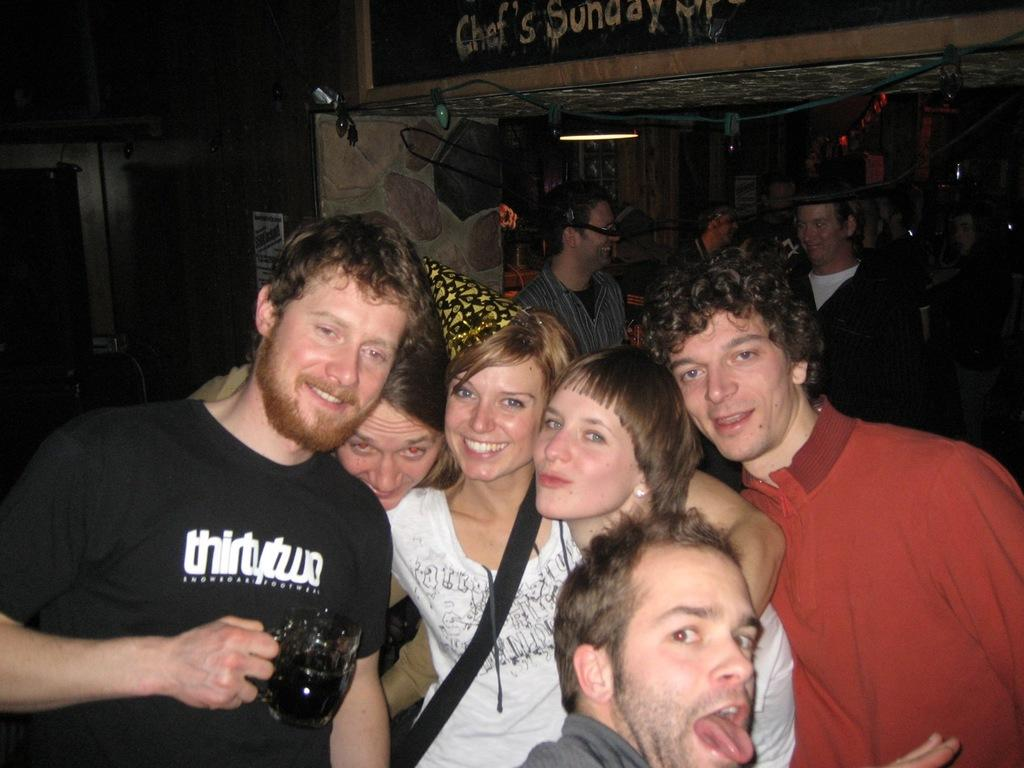<image>
Provide a brief description of the given image. a man that has the word thirty on his shirt 